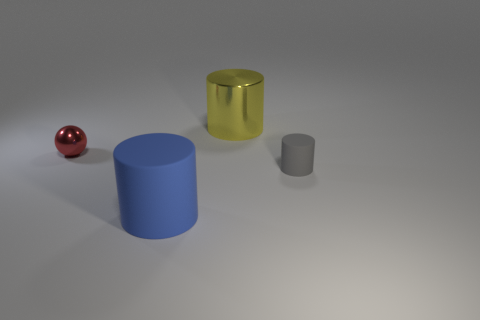Add 2 tiny matte cylinders. How many objects exist? 6 Subtract all balls. How many objects are left? 3 Add 2 big cylinders. How many big cylinders exist? 4 Subtract 1 red spheres. How many objects are left? 3 Subtract all large matte spheres. Subtract all red objects. How many objects are left? 3 Add 4 gray things. How many gray things are left? 5 